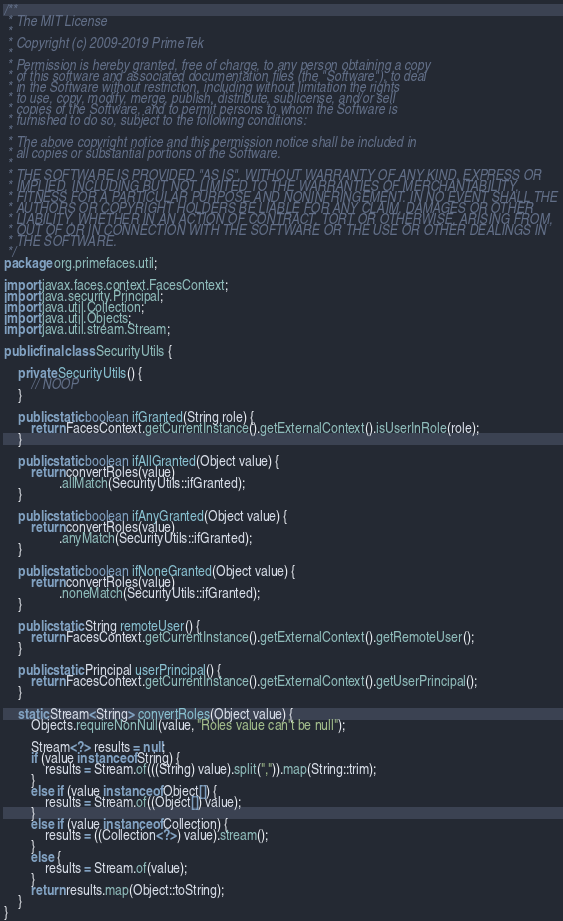Convert code to text. <code><loc_0><loc_0><loc_500><loc_500><_Java_>/**
 * The MIT License
 *
 * Copyright (c) 2009-2019 PrimeTek
 *
 * Permission is hereby granted, free of charge, to any person obtaining a copy
 * of this software and associated documentation files (the "Software"), to deal
 * in the Software without restriction, including without limitation the rights
 * to use, copy, modify, merge, publish, distribute, sublicense, and/or sell
 * copies of the Software, and to permit persons to whom the Software is
 * furnished to do so, subject to the following conditions:
 *
 * The above copyright notice and this permission notice shall be included in
 * all copies or substantial portions of the Software.
 *
 * THE SOFTWARE IS PROVIDED "AS IS", WITHOUT WARRANTY OF ANY KIND, EXPRESS OR
 * IMPLIED, INCLUDING BUT NOT LIMITED TO THE WARRANTIES OF MERCHANTABILITY,
 * FITNESS FOR A PARTICULAR PURPOSE AND NONINFRINGEMENT. IN NO EVENT SHALL THE
 * AUTHORS OR COPYRIGHT HOLDERS BE LIABLE FOR ANY CLAIM, DAMAGES OR OTHER
 * LIABILITY, WHETHER IN AN ACTION OF CONTRACT, TORT OR OTHERWISE, ARISING FROM,
 * OUT OF OR IN CONNECTION WITH THE SOFTWARE OR THE USE OR OTHER DEALINGS IN
 * THE SOFTWARE.
 */
package org.primefaces.util;

import javax.faces.context.FacesContext;
import java.security.Principal;
import java.util.Collection;
import java.util.Objects;
import java.util.stream.Stream;

public final class SecurityUtils {

    private SecurityUtils() {
        // NOOP
    }

    public static boolean ifGranted(String role) {
        return FacesContext.getCurrentInstance().getExternalContext().isUserInRole(role);
    }

    public static boolean ifAllGranted(Object value) {
        return convertRoles(value)
                .allMatch(SecurityUtils::ifGranted);
    }

    public static boolean ifAnyGranted(Object value) {
        return convertRoles(value)
                .anyMatch(SecurityUtils::ifGranted);
    }

    public static boolean ifNoneGranted(Object value) {
        return convertRoles(value)
                .noneMatch(SecurityUtils::ifGranted);
    }

    public static String remoteUser() {
        return FacesContext.getCurrentInstance().getExternalContext().getRemoteUser();
    }

    public static Principal userPrincipal() {
        return FacesContext.getCurrentInstance().getExternalContext().getUserPrincipal();
    }

    static Stream<String> convertRoles(Object value) {
        Objects.requireNonNull(value, "Roles value can't be null");

        Stream<?> results = null;
        if (value instanceof String) {
            results = Stream.of(((String) value).split(",")).map(String::trim);
        }
        else if (value instanceof Object[]) {
            results = Stream.of((Object[]) value);
        }
        else if (value instanceof Collection) {
            results = ((Collection<?>) value).stream();
        }
        else {
            results = Stream.of(value);
        }
        return results.map(Object::toString);
    }
}
</code> 